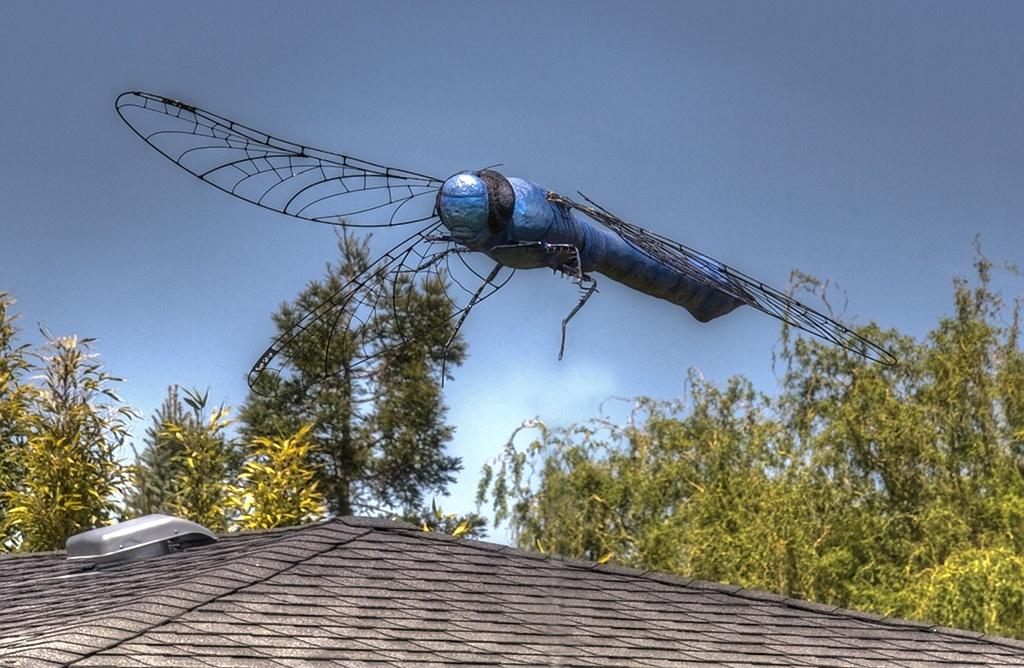What is the main subject of the image? There is a dragonfly-shaped object in the middle of the image. What type of natural elements can be seen in the image? There are trees visible in the image. What is visible at the top of the image? The sky is visible at the top of the image. Where is the dad standing with the cattle in the image? There is no dad or cattle present in the image; it features a dragonfly-shaped object and trees. What type of cracker is being used to feed the dragonfly in the image? There is no cracker present in the image, and dragonflies do not eat crackers. 